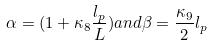<formula> <loc_0><loc_0><loc_500><loc_500>\alpha = ( 1 + \kappa _ { 8 } \frac { l _ { p } } { L } ) a n d \beta = \frac { \kappa _ { 9 } } { 2 } l _ { p }</formula> 